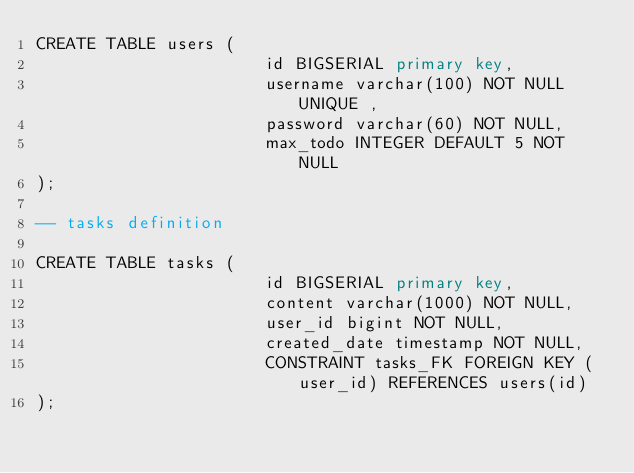<code> <loc_0><loc_0><loc_500><loc_500><_SQL_>CREATE TABLE users (
                       id BIGSERIAL primary key,
                       username varchar(100) NOT NULL UNIQUE ,
                       password varchar(60) NOT NULL,
                       max_todo INTEGER DEFAULT 5 NOT NULL
);

-- tasks definition

CREATE TABLE tasks (
                       id BIGSERIAL primary key,
                       content varchar(1000) NOT NULL,
                       user_id bigint NOT NULL,
                       created_date timestamp NOT NULL,
                       CONSTRAINT tasks_FK FOREIGN KEY (user_id) REFERENCES users(id)
);</code> 